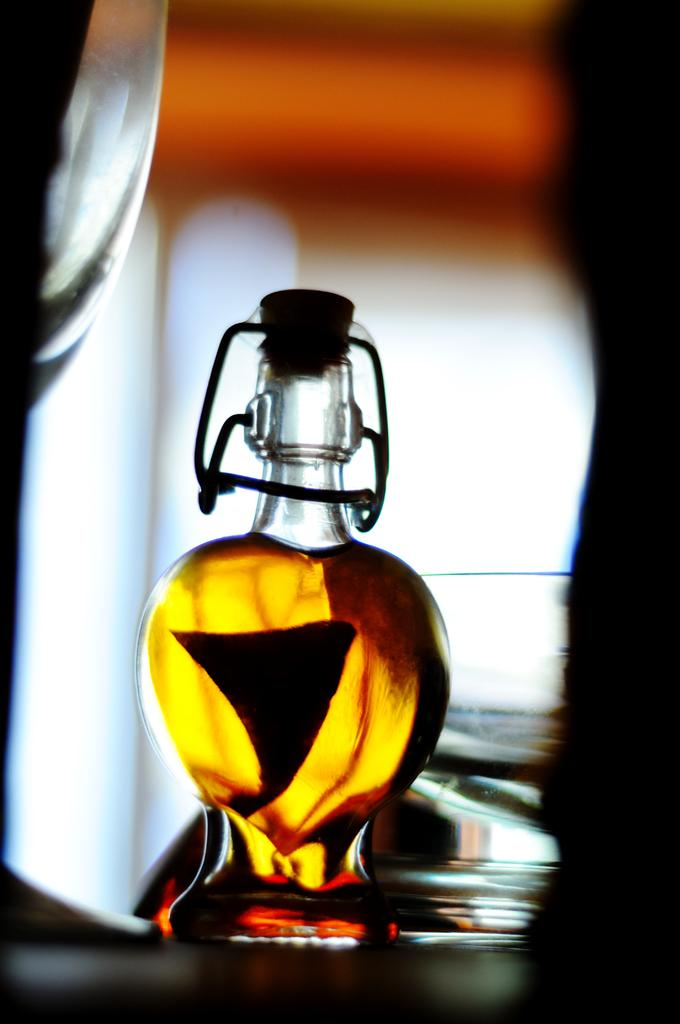What is one object visible in the image? There is a bottle in the image. How many glasses are present in the image? There are two glasses in the image. What type of crook can be seen in the image? There is no crook present in the image. What reason is given for the bottle and glasses being in the image? The image does not provide a reason for the presence of the bottle and glasses; it simply shows them. 